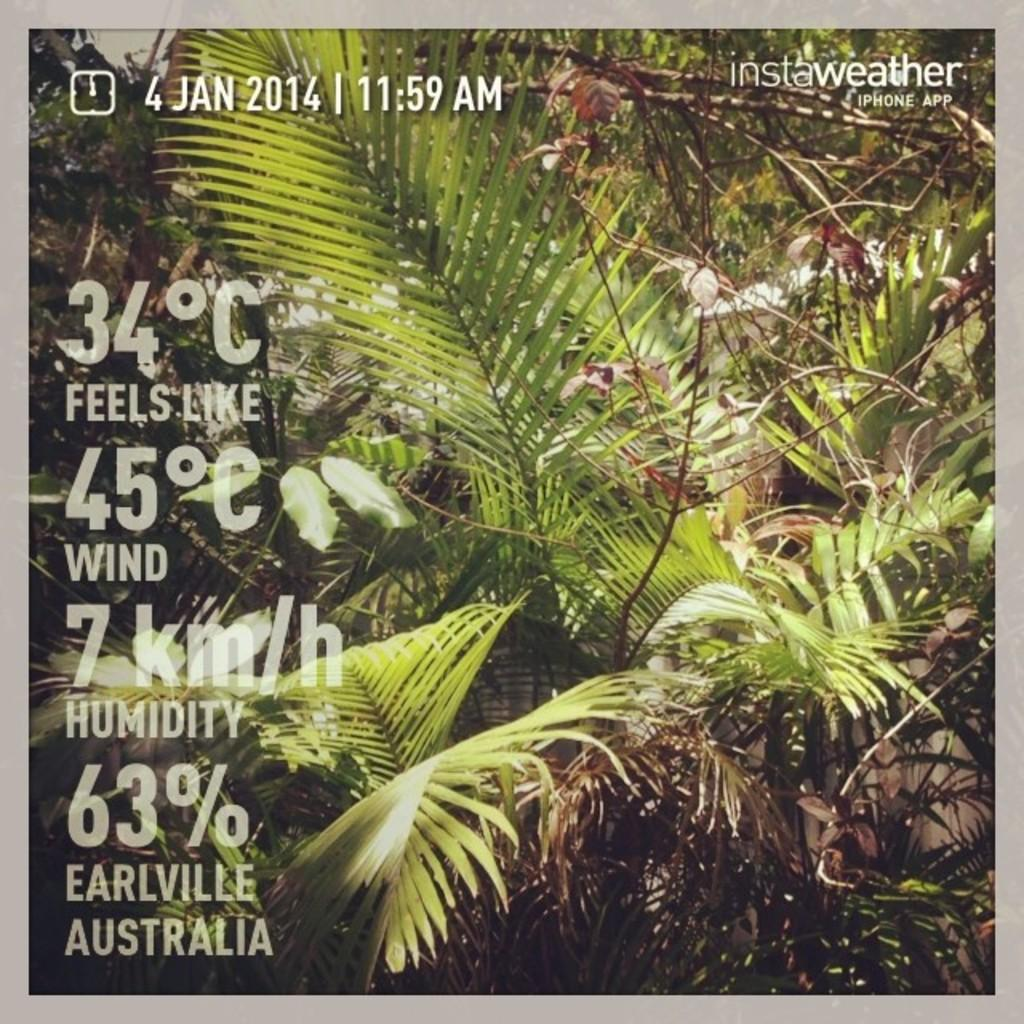What feature surrounds the main content of the image? The image has borders. What type of natural elements can be seen in the image? There are trees and plants in the image. Is there any text present in the image? Yes, there is text printed on the image. What type of sweater is being worn by the tree in the image? There are no people or clothing items present in the image, only trees and plants. 